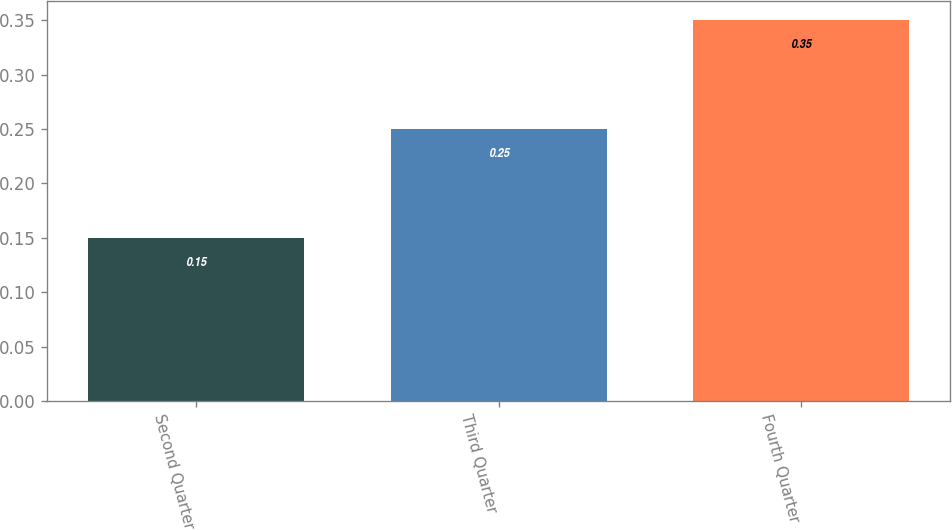<chart> <loc_0><loc_0><loc_500><loc_500><bar_chart><fcel>Second Quarter<fcel>Third Quarter<fcel>Fourth Quarter<nl><fcel>0.15<fcel>0.25<fcel>0.35<nl></chart> 